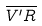<formula> <loc_0><loc_0><loc_500><loc_500>\overline { V ^ { \prime } R }</formula> 